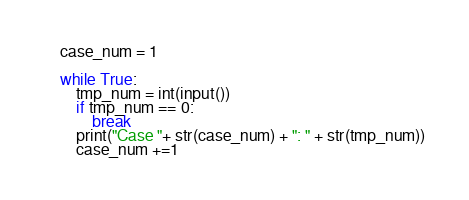Convert code to text. <code><loc_0><loc_0><loc_500><loc_500><_Python_>case_num = 1

while True:
    tmp_num = int(input())
    if tmp_num == 0:
        break
    print("Case "+ str(case_num) + ": " + str(tmp_num))
    case_num +=1
</code> 